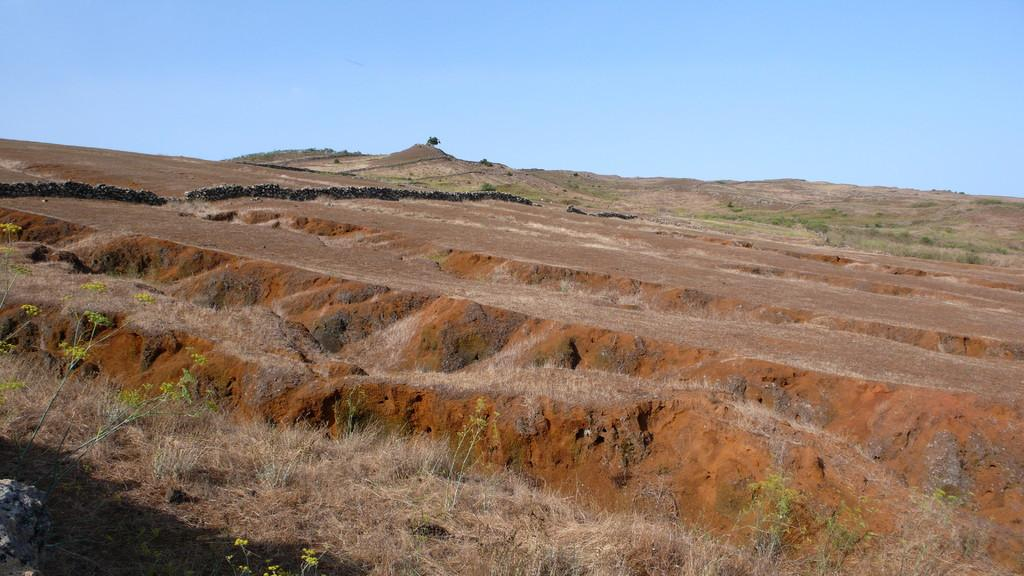What type of vegetation can be seen in the image? There are plants in the image. What is covering the ground in the image? There is grass on the ground in the image. What is visible at the top of the image? The sky is visible at the top of the image. What type of prose is being written in the image? There is no writing or prose present in the image; it features plants, grass, and the sky. Is there a jail visible in the image? There is no jail present in the image; it features plants, grass, and the sky. 